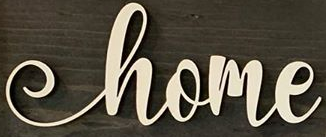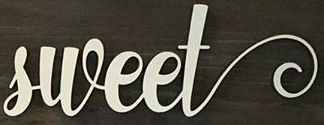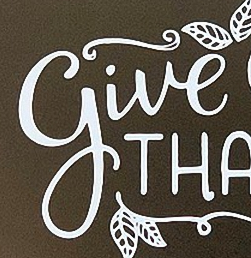Read the text from these images in sequence, separated by a semicolon. home; sweet; give 